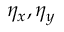<formula> <loc_0><loc_0><loc_500><loc_500>\eta _ { x } , \eta _ { y }</formula> 